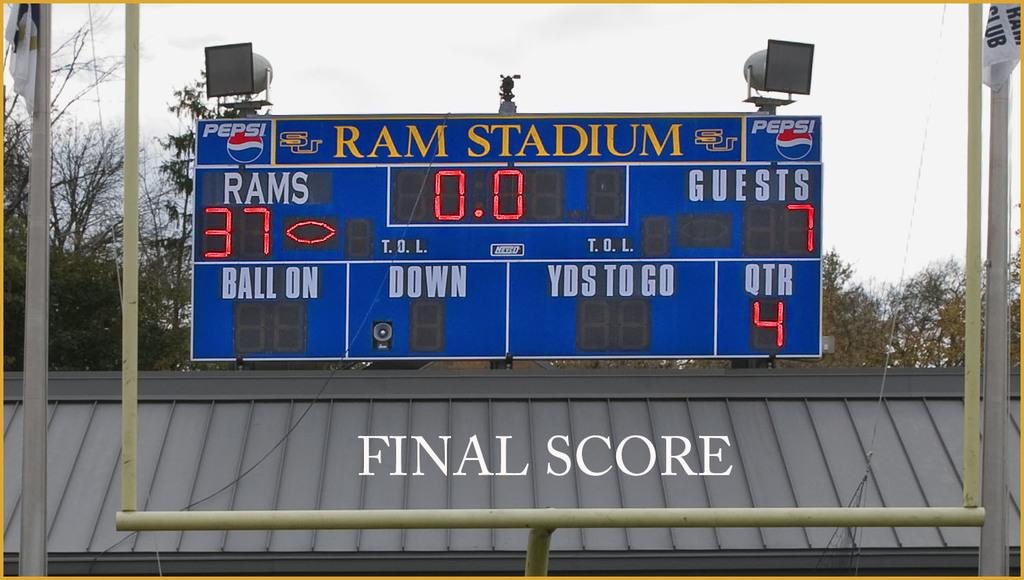<image>
Offer a succinct explanation of the picture presented. The scoreboard at Ram Stadium shows that the Rams got 37 points. 